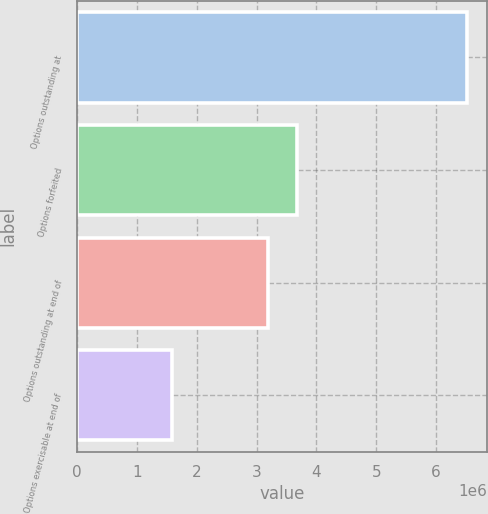Convert chart to OTSL. <chart><loc_0><loc_0><loc_500><loc_500><bar_chart><fcel>Options outstanding at<fcel>Options forfeited<fcel>Options outstanding at end of<fcel>Options exercisable at end of<nl><fcel>6.52706e+06<fcel>3.68083e+06<fcel>3.186e+06<fcel>1.5788e+06<nl></chart> 